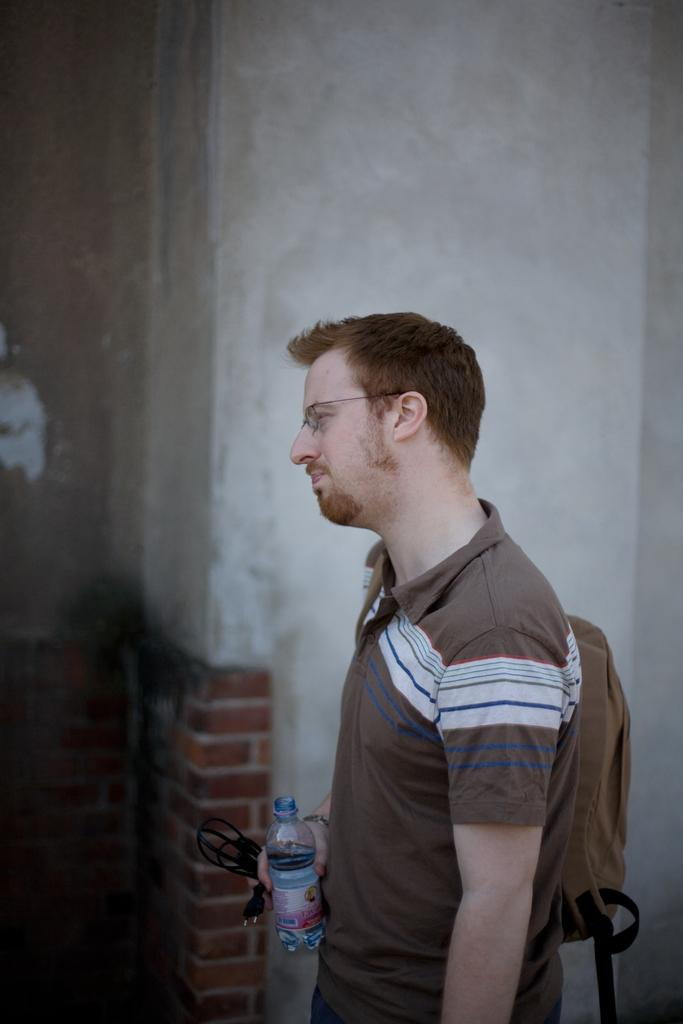Who is the person in the image? There is a man in the image. What is the man wearing? The man is wearing a brown color T-shirt. What else is the man carrying? The man is wearing a backpack bag and holding a water bottle. What is the man holding in his other hand? The man is holding a cable in his hand. What is the order of the items on the man's shopping list? There is no shopping list present in the image, so it is not possible to determine the order of any items. 